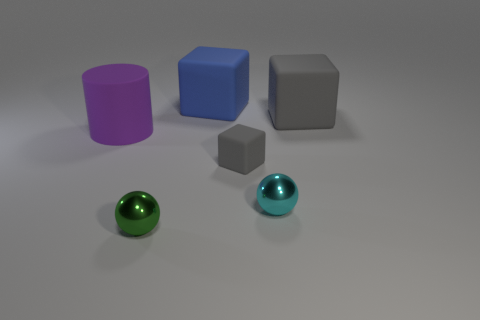What shape is the gray matte object that is the same size as the rubber cylinder?
Your answer should be compact. Cube. What is the material of the tiny sphere to the right of the gray object in front of the large rubber object right of the large blue rubber block?
Offer a very short reply. Metal. Does the gray rubber thing behind the purple rubber cylinder have the same shape as the rubber thing that is in front of the rubber cylinder?
Provide a succinct answer. Yes. How many other objects are there of the same material as the cyan object?
Provide a succinct answer. 1. Is the material of the purple cylinder that is behind the small matte thing the same as the tiny thing that is on the right side of the small gray thing?
Your answer should be very brief. No. What is the shape of the cyan object that is made of the same material as the green sphere?
Give a very brief answer. Sphere. Is there anything else that is the same color as the big cylinder?
Keep it short and to the point. No. What number of blue matte blocks are there?
Your answer should be compact. 1. There is a object that is in front of the big matte cylinder and left of the big blue rubber block; what shape is it?
Give a very brief answer. Sphere. The big matte object that is left of the block behind the gray matte object on the right side of the cyan shiny ball is what shape?
Provide a short and direct response. Cylinder. 